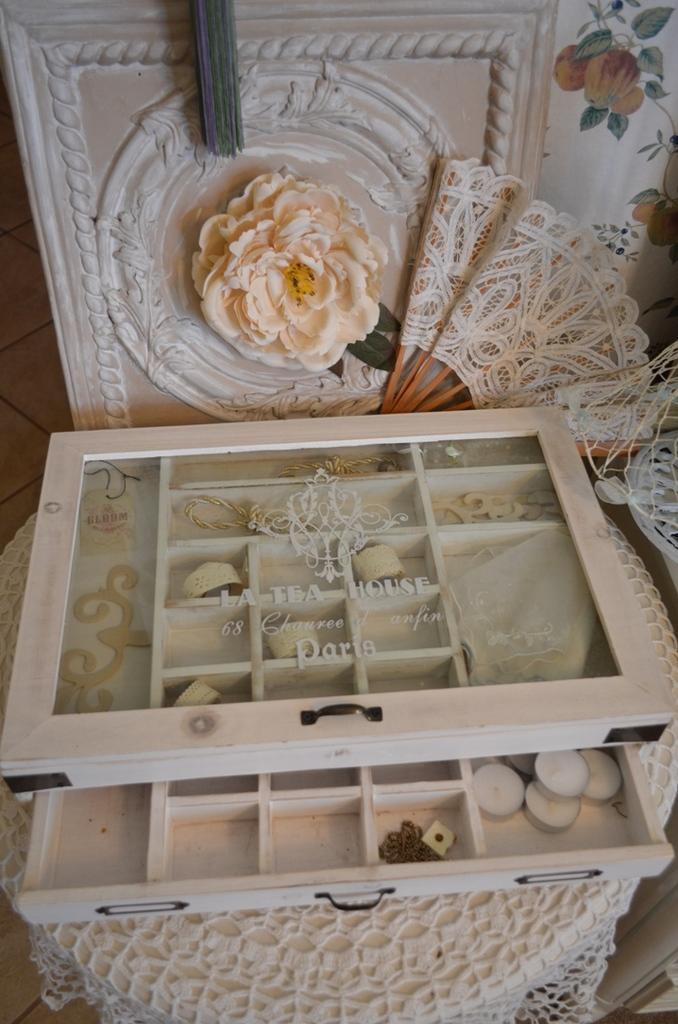Describe this image in one or two sentences. In this image we can see a box with different compartments and some candles are placed in the box. In the background,we can see a cloth and a flower. 